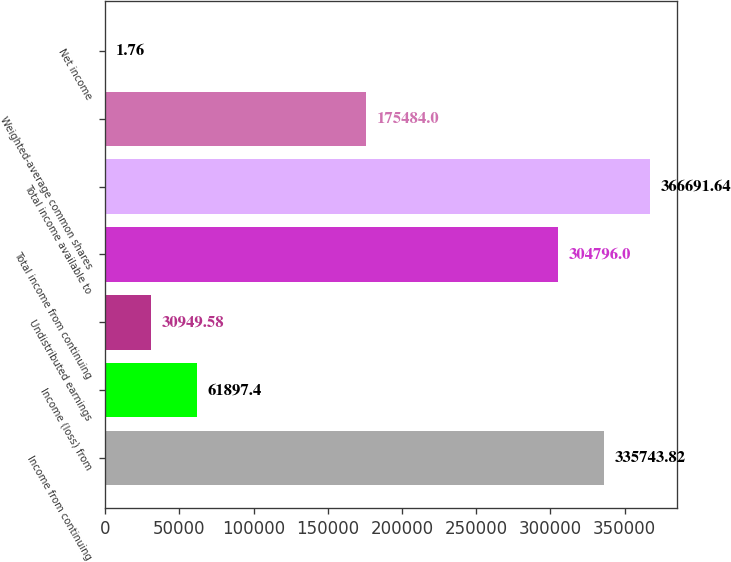Convert chart. <chart><loc_0><loc_0><loc_500><loc_500><bar_chart><fcel>Income from continuing<fcel>Income (loss) from<fcel>Undistributed earnings<fcel>Total income from continuing<fcel>Total income available to<fcel>Weighted-average common shares<fcel>Net income<nl><fcel>335744<fcel>61897.4<fcel>30949.6<fcel>304796<fcel>366692<fcel>175484<fcel>1.76<nl></chart> 